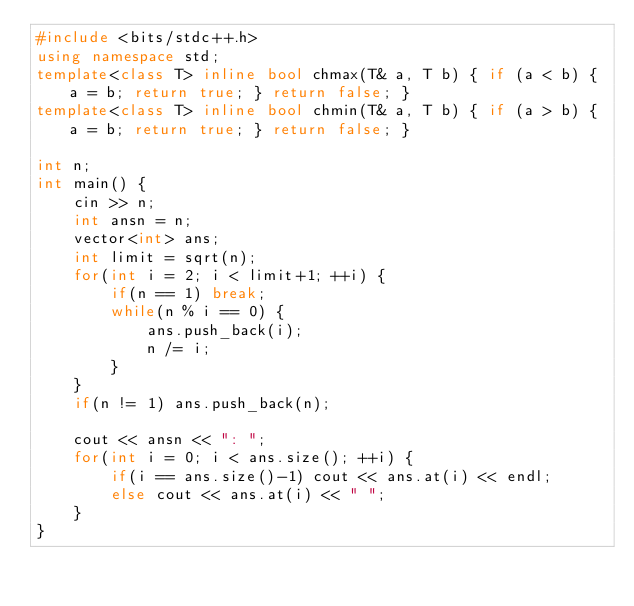Convert code to text. <code><loc_0><loc_0><loc_500><loc_500><_C++_>#include <bits/stdc++.h>
using namespace std;
template<class T> inline bool chmax(T& a, T b) { if (a < b) { a = b; return true; } return false; }
template<class T> inline bool chmin(T& a, T b) { if (a > b) { a = b; return true; } return false; }

int n;
int main() {
    cin >> n;
    int ansn = n;
    vector<int> ans;
    int limit = sqrt(n);
    for(int i = 2; i < limit+1; ++i) {
        if(n == 1) break;
        while(n % i == 0) {
            ans.push_back(i);
            n /= i;
        }
    }
    if(n != 1) ans.push_back(n);

    cout << ansn << ": ";
    for(int i = 0; i < ans.size(); ++i) {
        if(i == ans.size()-1) cout << ans.at(i) << endl;
        else cout << ans.at(i) << " ";
    }
}
</code> 